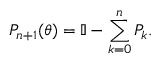Convert formula to latex. <formula><loc_0><loc_0><loc_500><loc_500>P _ { n + 1 } ( \theta ) = \mathbb { I } - \sum _ { k = 0 } ^ { n } P _ { k } .</formula> 